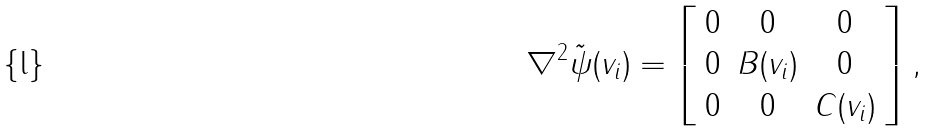Convert formula to latex. <formula><loc_0><loc_0><loc_500><loc_500>\nabla ^ { 2 } \tilde { \psi } ( v _ { i } ) = \left [ \begin{array} { c c c } 0 & 0 & 0 \\ 0 & B ( v _ { i } ) & 0 \\ 0 & 0 & C ( v _ { i } ) \end{array} \right ] ,</formula> 